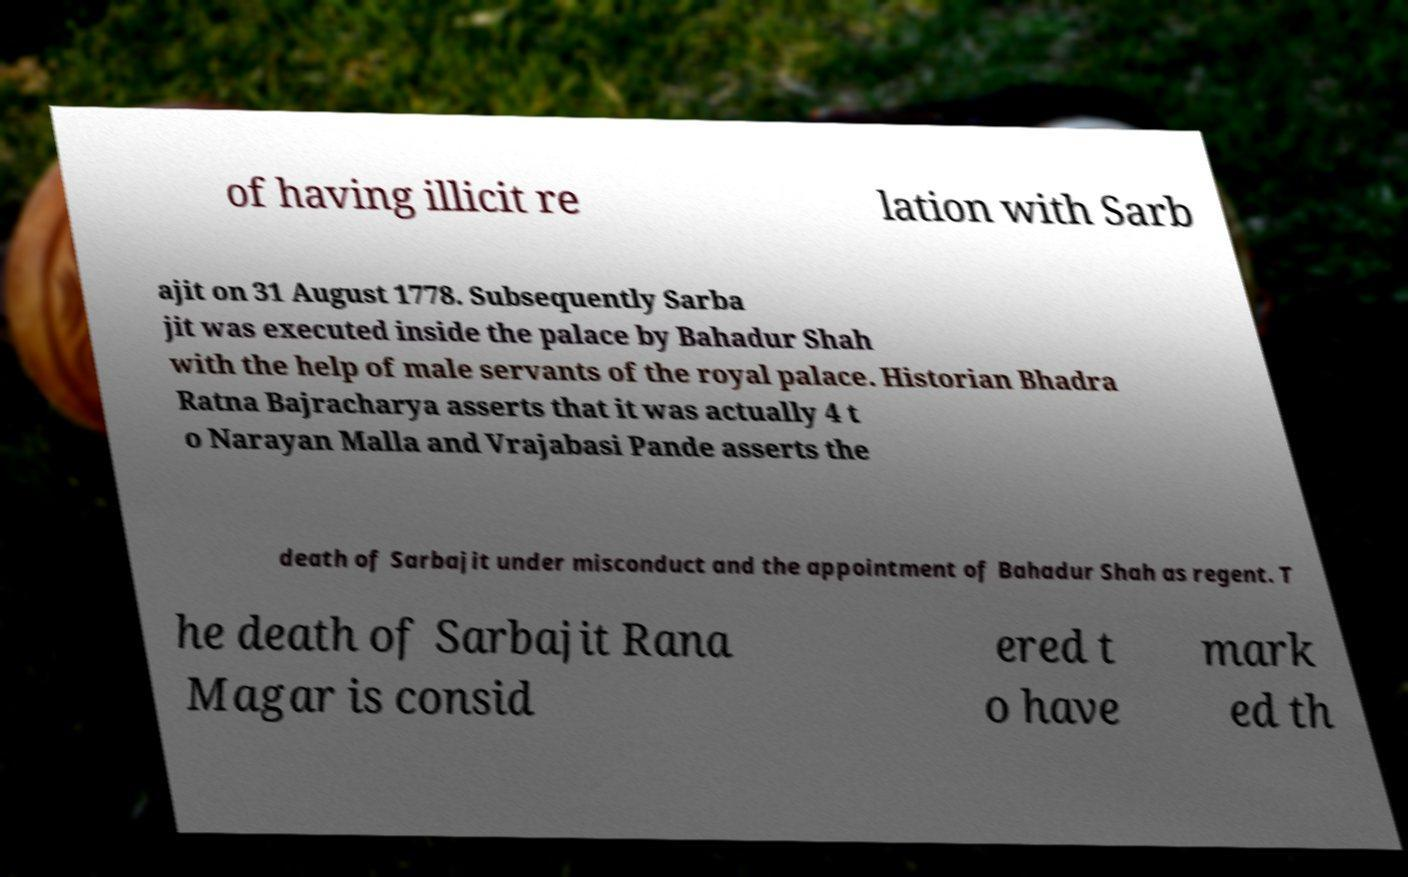There's text embedded in this image that I need extracted. Can you transcribe it verbatim? of having illicit re lation with Sarb ajit on 31 August 1778. Subsequently Sarba jit was executed inside the palace by Bahadur Shah with the help of male servants of the royal palace. Historian Bhadra Ratna Bajracharya asserts that it was actually 4 t o Narayan Malla and Vrajabasi Pande asserts the death of Sarbajit under misconduct and the appointment of Bahadur Shah as regent. T he death of Sarbajit Rana Magar is consid ered t o have mark ed th 